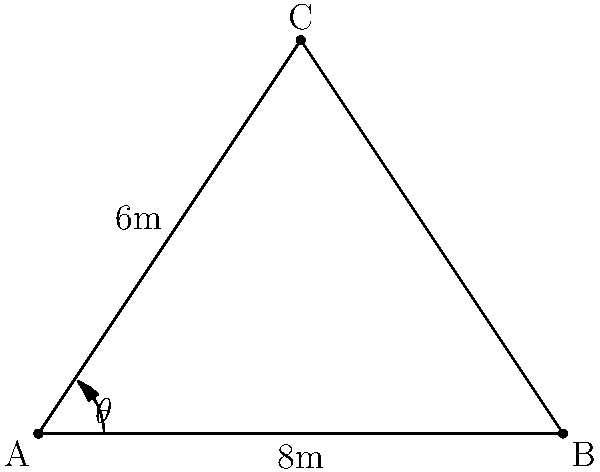In a Phoenix LPG game, you're at point A on the court, and two opponents are at points B and C. The distance between you and one opponent (AB) is 8 meters, and the distance between you and the other opponent (AC) is 6 meters. The angle between these two lines (∠BAC) is 53.13°. Calculate the distance between the two opponents (BC) using the law of cosines. Let's approach this step-by-step using the law of cosines:

1) The law of cosines states: 
   $$c^2 = a^2 + b^2 - 2ab \cos(C)$$
   where $c$ is the side opposite to angle $C$.

2) In our case:
   - $a = 8$ (side AB)
   - $b = 6$ (side AC)
   - $C = 53.13°$ (angle BAC)
   - We need to find $c$ (side BC)

3) Let's substitute these values into the formula:
   $$c^2 = 8^2 + 6^2 - 2(8)(6) \cos(53.13°)$$

4) Simplify:
   $$c^2 = 64 + 36 - 96 \cos(53.13°)$$

5) Calculate $\cos(53.13°)$:
   $$c^2 = 64 + 36 - 96(0.6)$$

6) Simplify:
   $$c^2 = 64 + 36 - 57.6 = 42.4$$

7) Take the square root of both sides:
   $$c = \sqrt{42.4} \approx 6.51$$

Therefore, the distance between the two opponents is approximately 6.51 meters.
Answer: 6.51 meters 